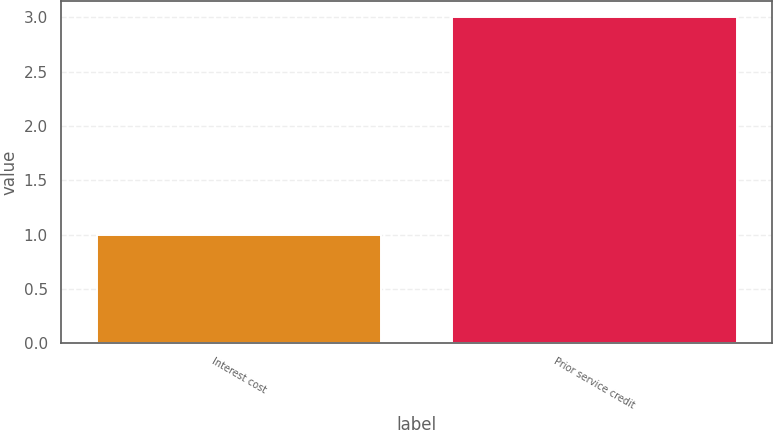<chart> <loc_0><loc_0><loc_500><loc_500><bar_chart><fcel>Interest cost<fcel>Prior service credit<nl><fcel>1<fcel>3<nl></chart> 